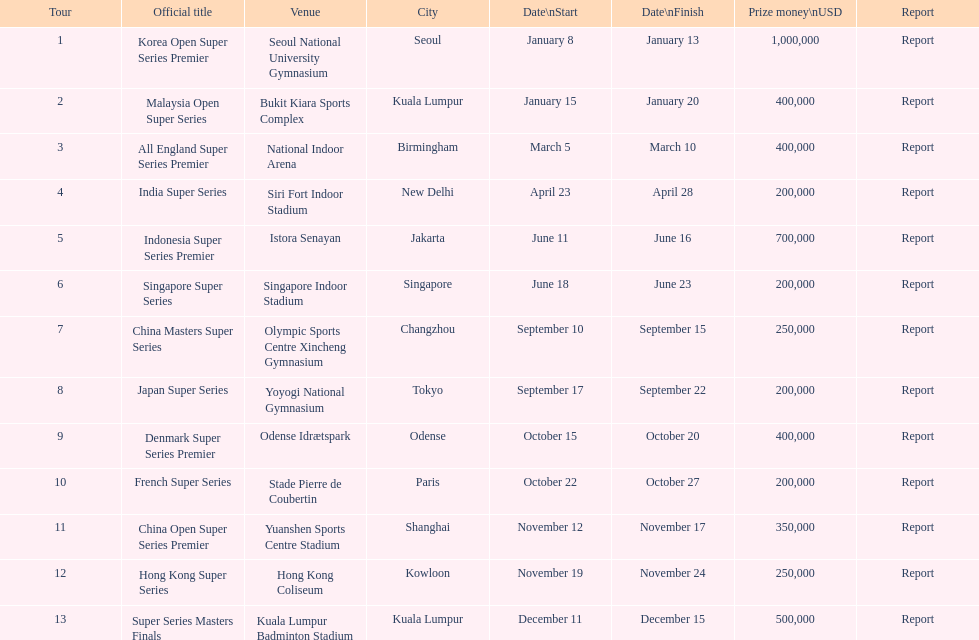What was the duration of the japan super series? 5 days. 